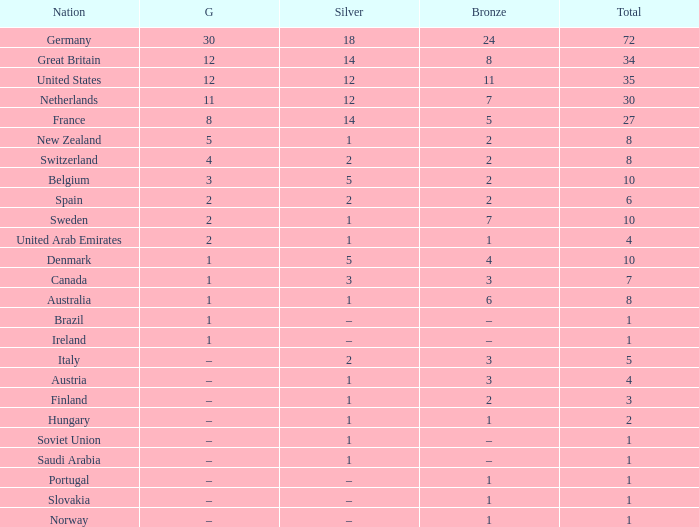What is Gold, when Bronze is 11? 12.0. 